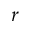<formula> <loc_0><loc_0><loc_500><loc_500>r</formula> 